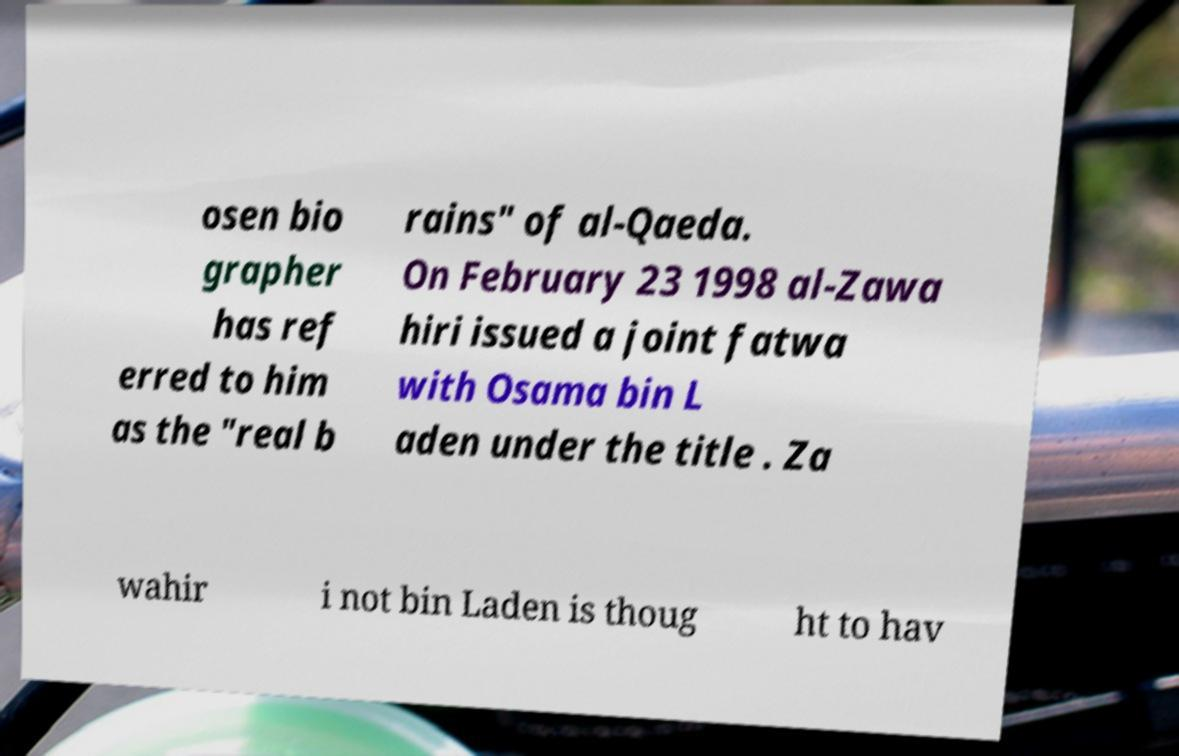There's text embedded in this image that I need extracted. Can you transcribe it verbatim? osen bio grapher has ref erred to him as the "real b rains" of al-Qaeda. On February 23 1998 al-Zawa hiri issued a joint fatwa with Osama bin L aden under the title . Za wahir i not bin Laden is thoug ht to hav 